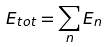<formula> <loc_0><loc_0><loc_500><loc_500>E _ { t o t } = \sum _ { n } E _ { n }</formula> 